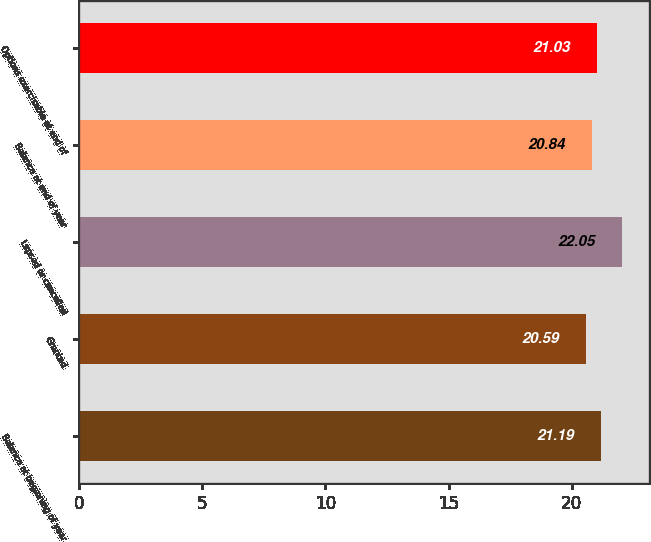Convert chart. <chart><loc_0><loc_0><loc_500><loc_500><bar_chart><fcel>Balance at beginning of year<fcel>Granted<fcel>Lapsed or cancelled<fcel>Balance at end of year<fcel>Options exercisable at end of<nl><fcel>21.19<fcel>20.59<fcel>22.05<fcel>20.84<fcel>21.03<nl></chart> 